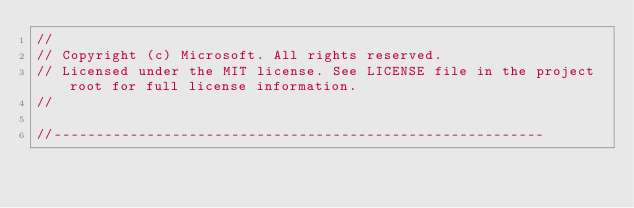<code> <loc_0><loc_0><loc_500><loc_500><_C++_>//
// Copyright (c) Microsoft. All rights reserved.
// Licensed under the MIT license. See LICENSE file in the project root for full license information.
//

//----------------------------------------------------------</code> 